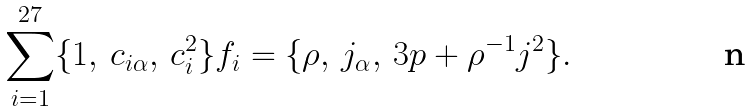<formula> <loc_0><loc_0><loc_500><loc_500>\sum _ { i = 1 } ^ { 2 7 } \{ 1 , \, c _ { i \alpha } , \, c _ { i } ^ { 2 } \} f _ { i } = \{ \rho , \, j _ { \alpha } , \, 3 p + \rho ^ { - 1 } j ^ { 2 } \} .</formula> 